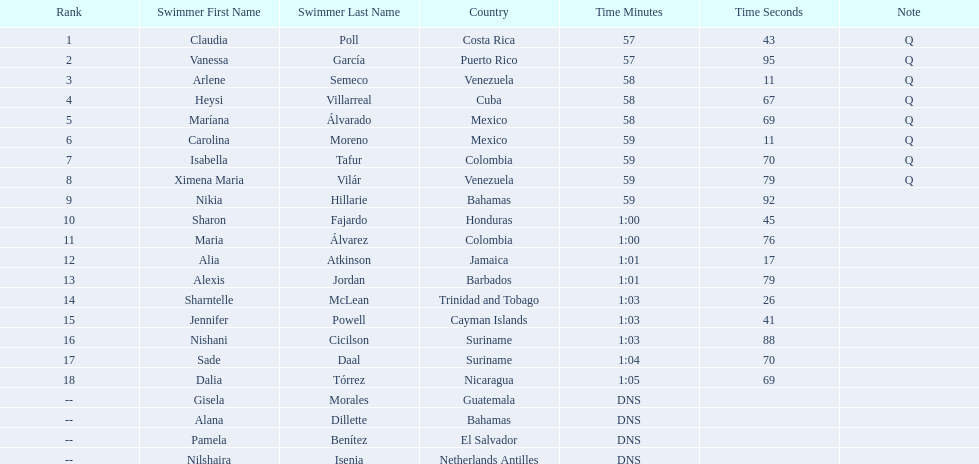How many competitors did not start the preliminaries? 4. 